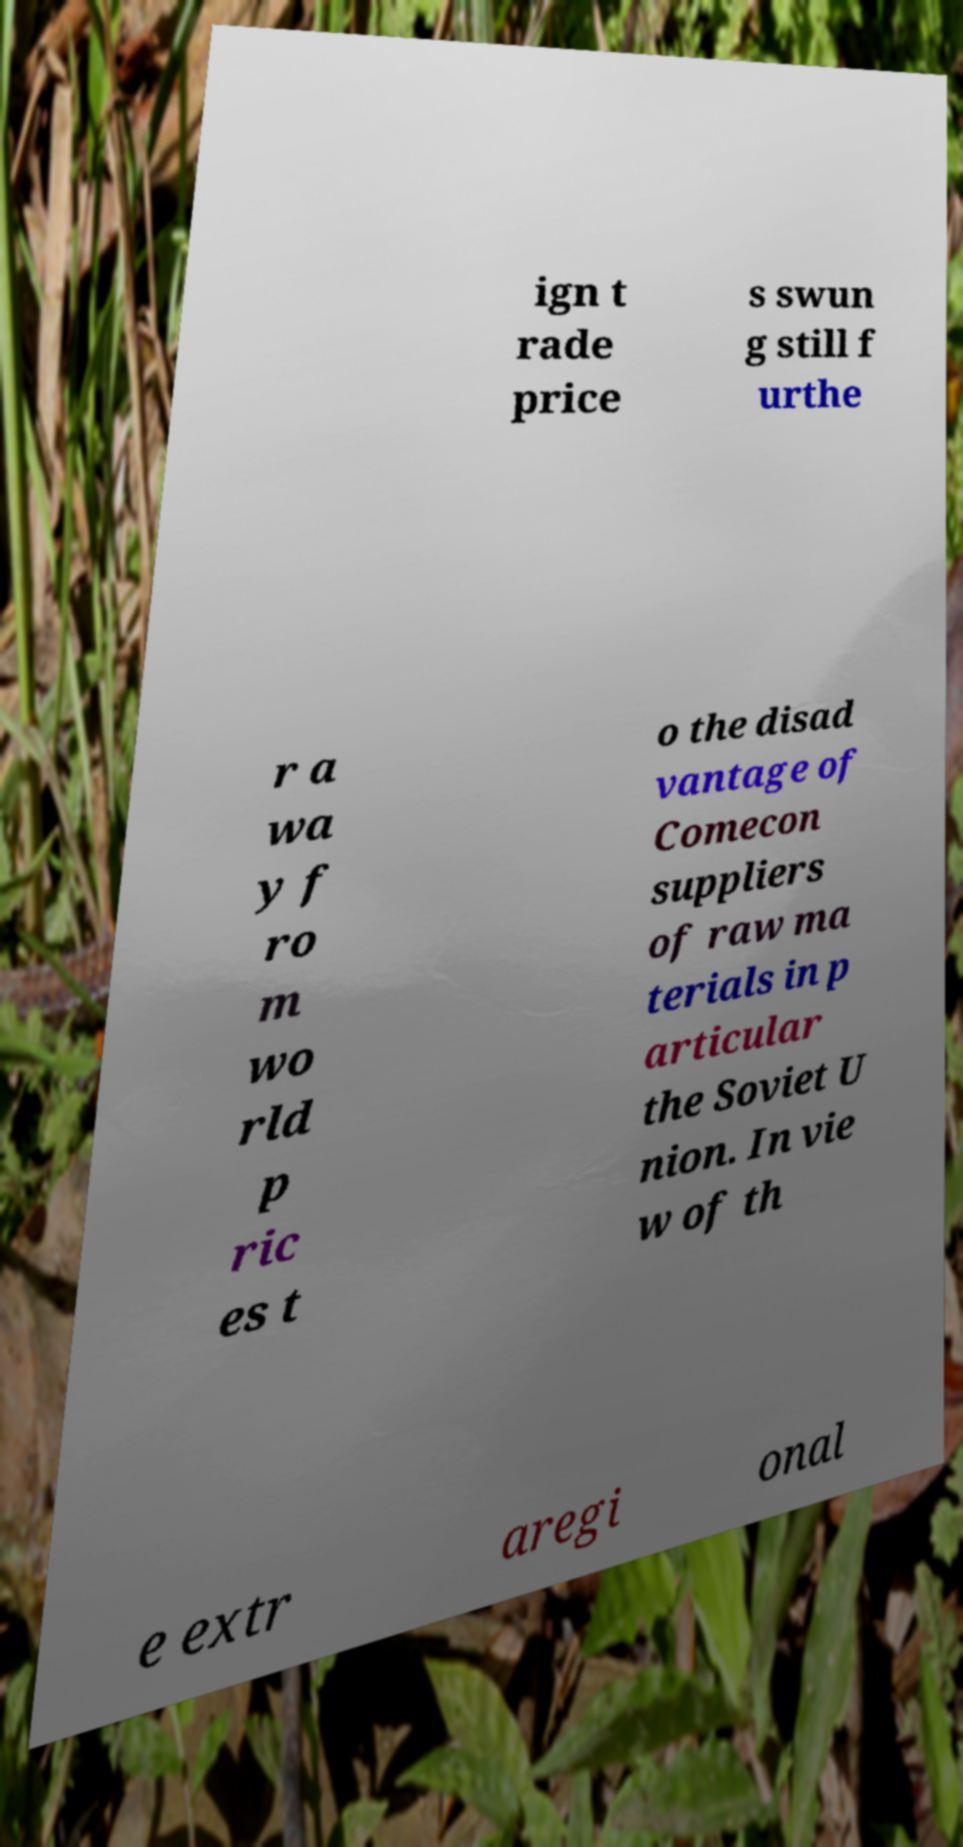For documentation purposes, I need the text within this image transcribed. Could you provide that? ign t rade price s swun g still f urthe r a wa y f ro m wo rld p ric es t o the disad vantage of Comecon suppliers of raw ma terials in p articular the Soviet U nion. In vie w of th e extr aregi onal 